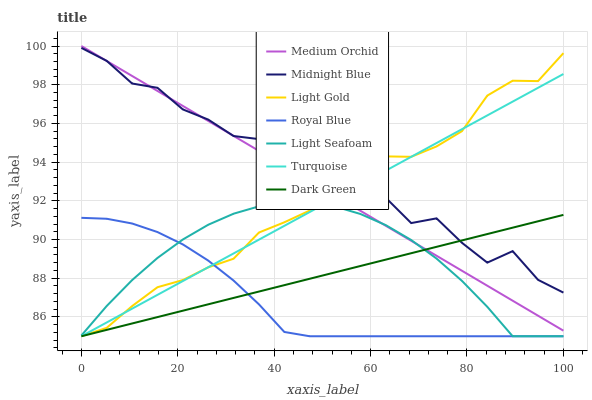Does Royal Blue have the minimum area under the curve?
Answer yes or no. Yes. Does Midnight Blue have the maximum area under the curve?
Answer yes or no. Yes. Does Medium Orchid have the minimum area under the curve?
Answer yes or no. No. Does Medium Orchid have the maximum area under the curve?
Answer yes or no. No. Is Turquoise the smoothest?
Answer yes or no. Yes. Is Midnight Blue the roughest?
Answer yes or no. Yes. Is Medium Orchid the smoothest?
Answer yes or no. No. Is Medium Orchid the roughest?
Answer yes or no. No. Does Medium Orchid have the lowest value?
Answer yes or no. No. Does Midnight Blue have the highest value?
Answer yes or no. No. Is Royal Blue less than Midnight Blue?
Answer yes or no. Yes. Is Midnight Blue greater than Royal Blue?
Answer yes or no. Yes. Does Royal Blue intersect Midnight Blue?
Answer yes or no. No. 